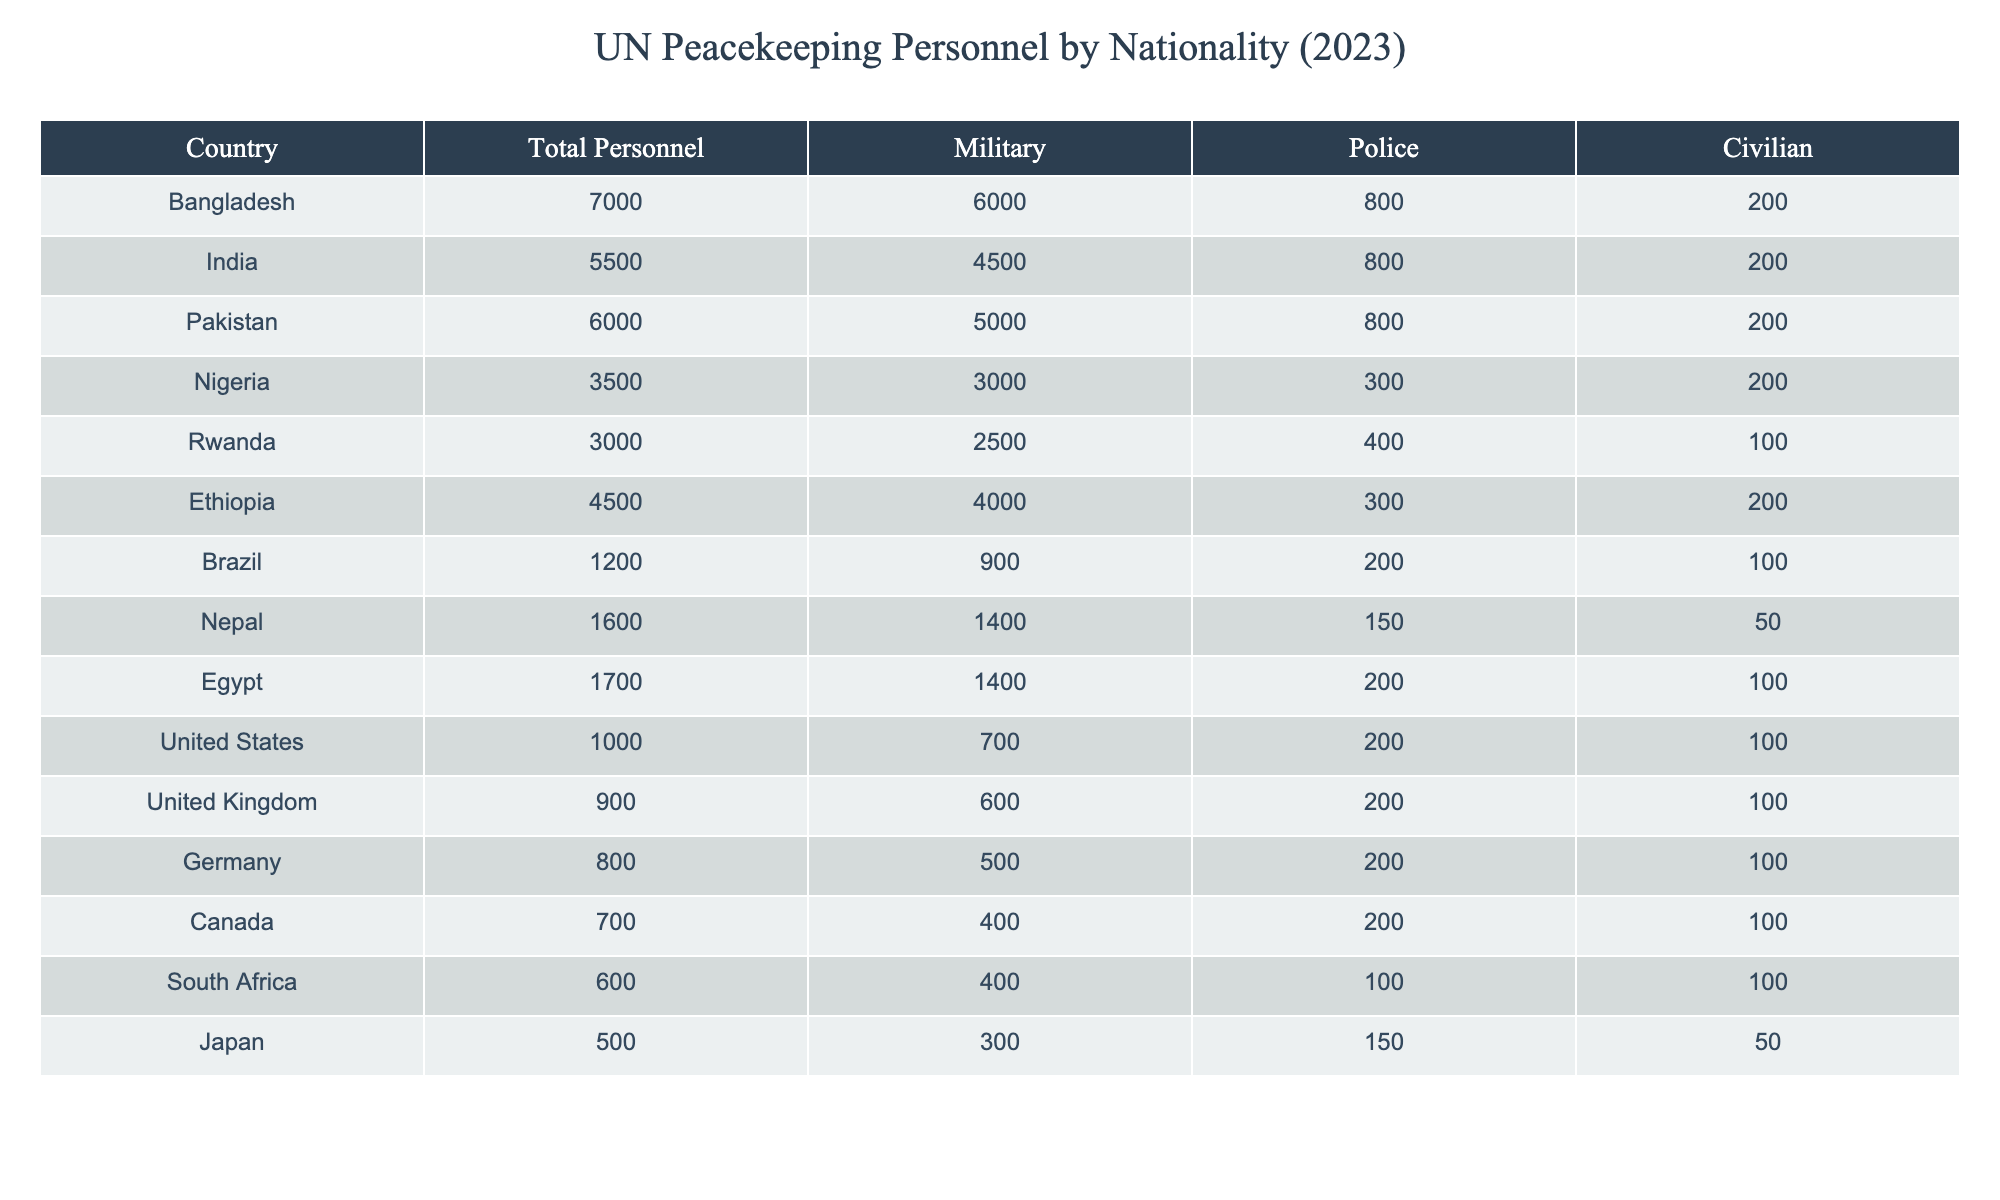What is the total number of peacekeeping personnel from Bangladesh? The table lists Bangladesh as having a total of 7000 personnel. This number directly corresponds to the value in the "Total Personnel" column for Bangladesh.
Answer: 7000 Which country has the highest number of military personnel in peacekeeping missions? By examining the "Military" column, Bangladesh shows 6000 military personnel, which is the highest figure compared to other countries listed.
Answer: Bangladesh What is the total number of police personnel from India and Pakistan combined? The police personnel from India is 800 and from Pakistan is also 800. Adding these two values gives 800 + 800 = 1600.
Answer: 1600 Is it true that Nigeria has more total personnel than Rwanda? Referring to the "Total Personnel" column, Nigeria has 3500 and Rwanda has 3000. Since 3500 is greater than 3000, the statement is true.
Answer: Yes What percentage of the total personnel from Ethiopia are military personnel? Ethiopia has a total of 4500 personnel, out of which 4000 are military. To find the percentage, the calculation is (4000 / 4500) * 100 = 88.89%.
Answer: 88.89% Which country has a total personnel number closest to that of Germany? Germany has 800 total personnel, while Canada has 700, which is the closest lower number. Thus, the country with the closest total personnel to Germany is Canada.
Answer: Canada What is the average number of civilian personnel for the countries listed in the table? The civilian personnel values are: 200, 200, 200, 100, 200, 200, 100, 50, 100, 100, 100, 100, 50. Summing these gives 200 + 200 + 200 + 100 + 200 + 200 + 100 + 50 + 100 + 100 + 100 + 100 + 50 = 2100. There are 13 countries, so the average is 2100 / 13 ≈ 161.54.
Answer: 161.54 How many countries have more police personnel than civilian personnel? By reviewing the table, we see that military and police personnel values for each country are compared to their respective civilian values. After checking, it is found that only 8 countries have police personnel exceeding civilian numbers.
Answer: 8 What is the difference between the total personnel numbers of the top two countries? The top two countries are Bangladesh with 7000 personnel and India with 5500 personnel. The difference is 7000 - 5500 = 1500.
Answer: 1500 